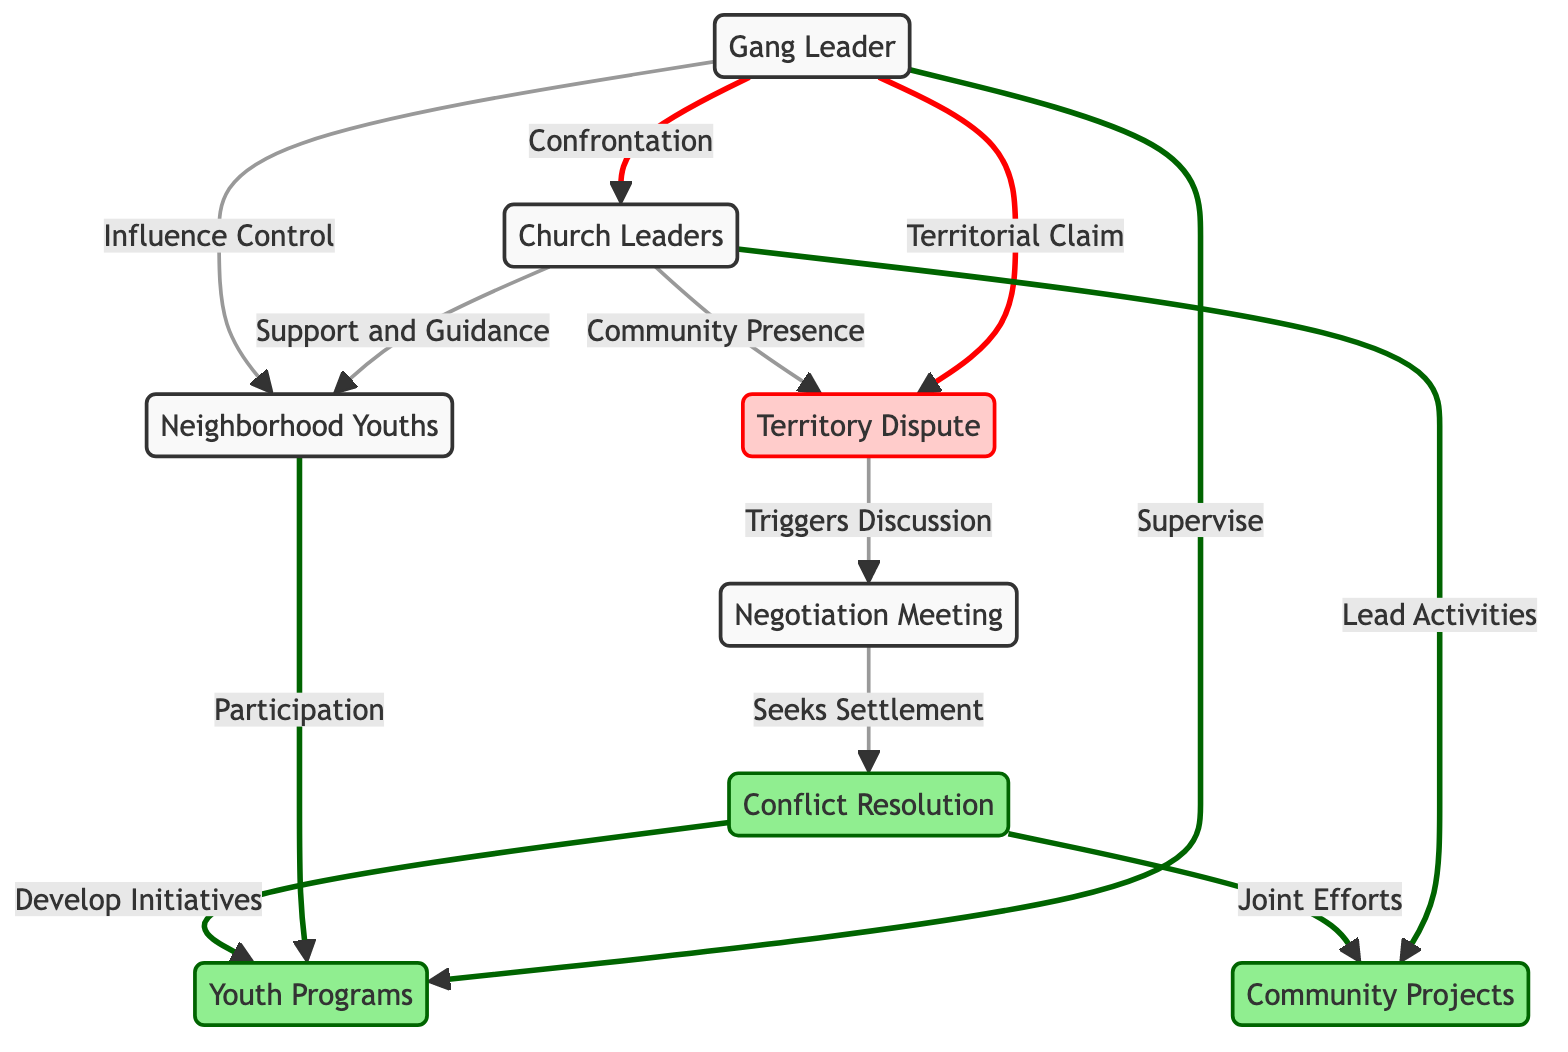What is the primary conflict identified in the diagram? The diagram specifies the "Territory Dispute" as the central conflict, indicated by the specific conflict node that connects both the gang leader and church leaders.
Answer: Territory Dispute How do church leaders influence neighborhood youths? The connection in the diagram shows that church leaders provide "Support and Guidance" to the neighborhood youths, represented by the arrow leading from church leaders to youths.
Answer: Support and Guidance What type of events follow the negotiation meeting? The diagram illustrates that after the "Negotiation Meeting," there are two potential resolutions: "Conflict Resolution" and subsequent community initiatives. Hence, the events that follow are both conflict resolution processes and community projects.
Answer: Conflict Resolution, Community Projects Which entity supervises the youth programs? The diagram indicates that the gang leader has the role of supervising the youth programs, as depicted by the arrow leading from the gang leader to the "Youth Programs" node.
Answer: Supervise What actions lead to the conflict resolution process? According to the diagram, the actions leading to the "Conflict Resolution" include the "Territory Dispute" triggering a "Negotiation Meeting," which then seeks a settlement. These actions show a clear flow toward resolving the conflict.
Answer: Territory Dispute triggers Negotiation Meeting How many resolutions are depicted in the diagram? The diagram shows two main resolutions emerging from the "Conflict Resolution" node: "Community Projects" and "Youth Programs," denoting a total of two resolutions.
Answer: Two What is the role of youths in the community projects? The diagram specifies that youths participate in "Youth Programs," which are connected to the community projects that arise from conflict resolution, indicating active involvement from the youths’ side.
Answer: Participation What relationship do church leaders have with community projects? The relationship is depicted clearly in the diagram, where church leaders are set to "Lead Activities" associated with the "Community Projects," establishing their involvement in the community initiatives.
Answer: Lead Activities 